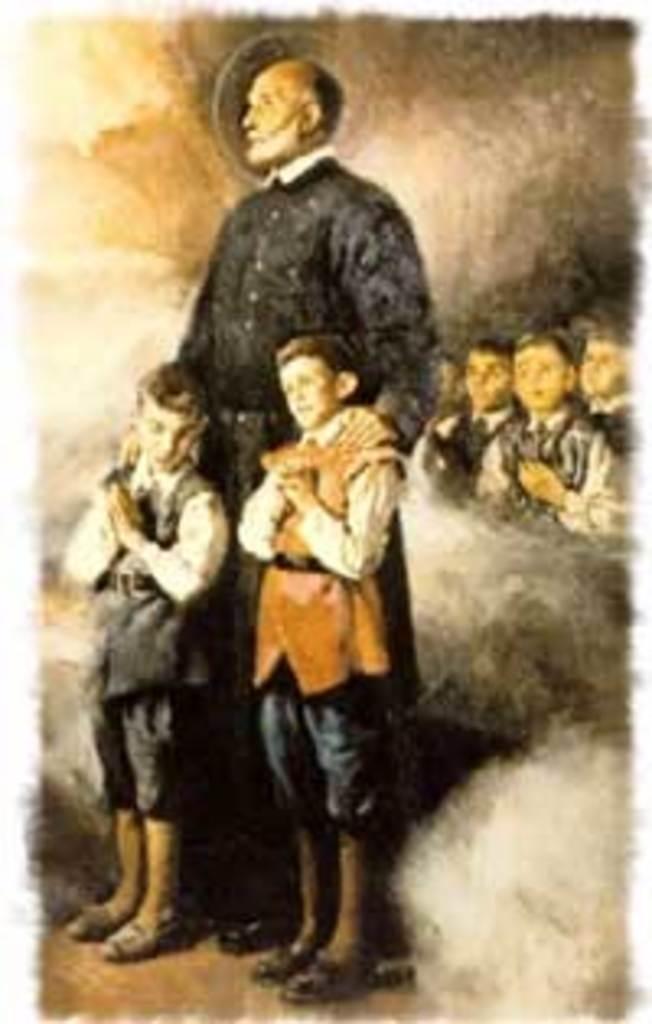Can you describe this image briefly? This is an animated image. In the foreground of the picture there are two kids and a man standing. On the right there are kids standing, around them it is smoke. 